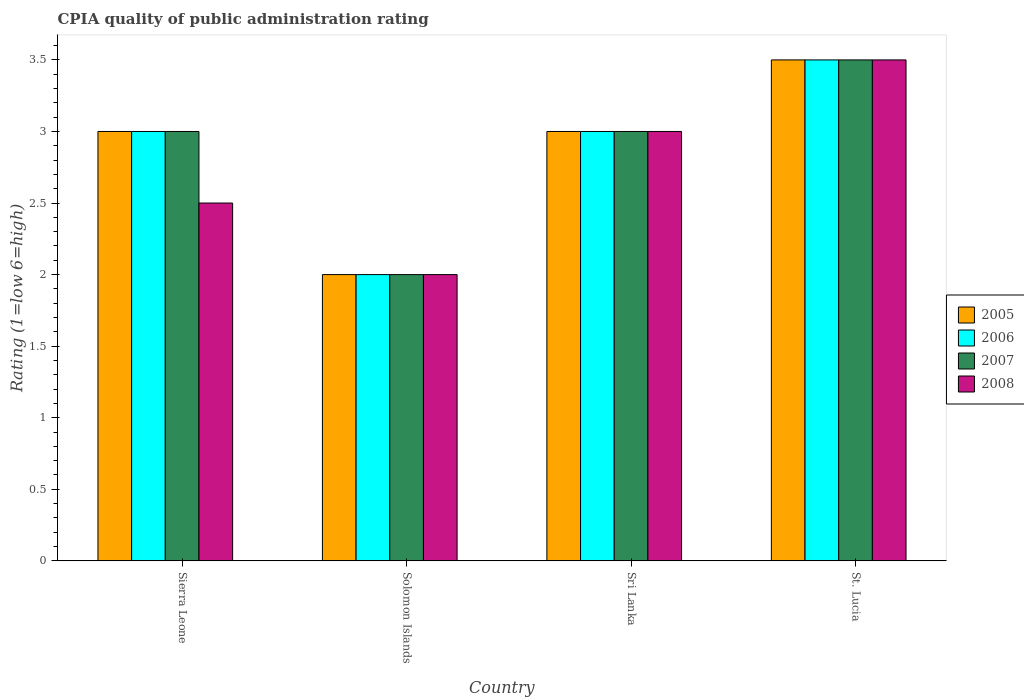How many different coloured bars are there?
Keep it short and to the point. 4. Are the number of bars per tick equal to the number of legend labels?
Your answer should be compact. Yes. How many bars are there on the 1st tick from the right?
Your answer should be very brief. 4. What is the label of the 1st group of bars from the left?
Keep it short and to the point. Sierra Leone. What is the CPIA rating in 2008 in Sierra Leone?
Offer a very short reply. 2.5. Across all countries, what is the minimum CPIA rating in 2008?
Offer a terse response. 2. In which country was the CPIA rating in 2005 maximum?
Keep it short and to the point. St. Lucia. In which country was the CPIA rating in 2006 minimum?
Ensure brevity in your answer.  Solomon Islands. What is the difference between the CPIA rating in 2005 in Sierra Leone and that in Sri Lanka?
Provide a short and direct response. 0. What is the average CPIA rating in 2007 per country?
Keep it short and to the point. 2.88. What is the ratio of the CPIA rating in 2008 in Sierra Leone to that in Sri Lanka?
Provide a succinct answer. 0.83. Is the CPIA rating in 2007 in Solomon Islands less than that in St. Lucia?
Provide a succinct answer. Yes. What is the difference between the highest and the second highest CPIA rating in 2005?
Your answer should be compact. -0.5. What is the difference between the highest and the lowest CPIA rating in 2008?
Your answer should be compact. 1.5. In how many countries, is the CPIA rating in 2005 greater than the average CPIA rating in 2005 taken over all countries?
Ensure brevity in your answer.  3. Is the sum of the CPIA rating in 2008 in Sierra Leone and Solomon Islands greater than the maximum CPIA rating in 2005 across all countries?
Ensure brevity in your answer.  Yes. Is it the case that in every country, the sum of the CPIA rating in 2006 and CPIA rating in 2008 is greater than the sum of CPIA rating in 2007 and CPIA rating in 2005?
Offer a very short reply. No. What does the 1st bar from the right in Sri Lanka represents?
Ensure brevity in your answer.  2008. Is it the case that in every country, the sum of the CPIA rating in 2007 and CPIA rating in 2008 is greater than the CPIA rating in 2005?
Provide a succinct answer. Yes. Are all the bars in the graph horizontal?
Keep it short and to the point. No. How many countries are there in the graph?
Provide a succinct answer. 4. How many legend labels are there?
Provide a succinct answer. 4. How are the legend labels stacked?
Provide a short and direct response. Vertical. What is the title of the graph?
Provide a short and direct response. CPIA quality of public administration rating. What is the label or title of the X-axis?
Keep it short and to the point. Country. What is the Rating (1=low 6=high) in 2008 in Sierra Leone?
Your answer should be compact. 2.5. What is the Rating (1=low 6=high) in 2005 in Sri Lanka?
Your answer should be very brief. 3. What is the Rating (1=low 6=high) in 2006 in Sri Lanka?
Provide a succinct answer. 3. What is the Rating (1=low 6=high) of 2007 in Sri Lanka?
Your answer should be very brief. 3. What is the Rating (1=low 6=high) in 2008 in Sri Lanka?
Provide a short and direct response. 3. What is the Rating (1=low 6=high) in 2006 in St. Lucia?
Make the answer very short. 3.5. What is the Rating (1=low 6=high) of 2008 in St. Lucia?
Your response must be concise. 3.5. Across all countries, what is the maximum Rating (1=low 6=high) of 2005?
Your answer should be very brief. 3.5. Across all countries, what is the maximum Rating (1=low 6=high) in 2007?
Offer a very short reply. 3.5. Across all countries, what is the maximum Rating (1=low 6=high) in 2008?
Give a very brief answer. 3.5. Across all countries, what is the minimum Rating (1=low 6=high) in 2005?
Keep it short and to the point. 2. What is the total Rating (1=low 6=high) of 2005 in the graph?
Make the answer very short. 11.5. What is the total Rating (1=low 6=high) in 2007 in the graph?
Provide a succinct answer. 11.5. What is the total Rating (1=low 6=high) of 2008 in the graph?
Provide a short and direct response. 11. What is the difference between the Rating (1=low 6=high) in 2006 in Sierra Leone and that in Solomon Islands?
Your answer should be very brief. 1. What is the difference between the Rating (1=low 6=high) of 2006 in Sierra Leone and that in St. Lucia?
Ensure brevity in your answer.  -0.5. What is the difference between the Rating (1=low 6=high) of 2007 in Sierra Leone and that in St. Lucia?
Offer a very short reply. -0.5. What is the difference between the Rating (1=low 6=high) of 2005 in Solomon Islands and that in Sri Lanka?
Your answer should be compact. -1. What is the difference between the Rating (1=low 6=high) of 2006 in Solomon Islands and that in Sri Lanka?
Offer a very short reply. -1. What is the difference between the Rating (1=low 6=high) of 2007 in Solomon Islands and that in Sri Lanka?
Make the answer very short. -1. What is the difference between the Rating (1=low 6=high) in 2008 in Solomon Islands and that in Sri Lanka?
Keep it short and to the point. -1. What is the difference between the Rating (1=low 6=high) of 2005 in Solomon Islands and that in St. Lucia?
Keep it short and to the point. -1.5. What is the difference between the Rating (1=low 6=high) in 2006 in Solomon Islands and that in St. Lucia?
Keep it short and to the point. -1.5. What is the difference between the Rating (1=low 6=high) of 2007 in Solomon Islands and that in St. Lucia?
Your response must be concise. -1.5. What is the difference between the Rating (1=low 6=high) of 2005 in Sri Lanka and that in St. Lucia?
Your answer should be very brief. -0.5. What is the difference between the Rating (1=low 6=high) in 2005 in Sierra Leone and the Rating (1=low 6=high) in 2006 in Solomon Islands?
Ensure brevity in your answer.  1. What is the difference between the Rating (1=low 6=high) of 2007 in Sierra Leone and the Rating (1=low 6=high) of 2008 in Solomon Islands?
Your response must be concise. 1. What is the difference between the Rating (1=low 6=high) of 2006 in Sierra Leone and the Rating (1=low 6=high) of 2008 in Sri Lanka?
Give a very brief answer. 0. What is the difference between the Rating (1=low 6=high) in 2005 in Sierra Leone and the Rating (1=low 6=high) in 2006 in St. Lucia?
Provide a succinct answer. -0.5. What is the difference between the Rating (1=low 6=high) in 2006 in Sierra Leone and the Rating (1=low 6=high) in 2007 in St. Lucia?
Offer a very short reply. -0.5. What is the difference between the Rating (1=low 6=high) of 2007 in Sierra Leone and the Rating (1=low 6=high) of 2008 in St. Lucia?
Provide a short and direct response. -0.5. What is the difference between the Rating (1=low 6=high) in 2005 in Solomon Islands and the Rating (1=low 6=high) in 2006 in Sri Lanka?
Give a very brief answer. -1. What is the difference between the Rating (1=low 6=high) in 2006 in Solomon Islands and the Rating (1=low 6=high) in 2007 in Sri Lanka?
Your response must be concise. -1. What is the difference between the Rating (1=low 6=high) of 2007 in Solomon Islands and the Rating (1=low 6=high) of 2008 in Sri Lanka?
Ensure brevity in your answer.  -1. What is the difference between the Rating (1=low 6=high) of 2005 in Solomon Islands and the Rating (1=low 6=high) of 2006 in St. Lucia?
Provide a short and direct response. -1.5. What is the difference between the Rating (1=low 6=high) in 2005 in Solomon Islands and the Rating (1=low 6=high) in 2007 in St. Lucia?
Provide a succinct answer. -1.5. What is the difference between the Rating (1=low 6=high) in 2005 in Solomon Islands and the Rating (1=low 6=high) in 2008 in St. Lucia?
Offer a terse response. -1.5. What is the difference between the Rating (1=low 6=high) of 2006 in Solomon Islands and the Rating (1=low 6=high) of 2007 in St. Lucia?
Keep it short and to the point. -1.5. What is the difference between the Rating (1=low 6=high) in 2006 in Solomon Islands and the Rating (1=low 6=high) in 2008 in St. Lucia?
Provide a short and direct response. -1.5. What is the difference between the Rating (1=low 6=high) of 2005 in Sri Lanka and the Rating (1=low 6=high) of 2006 in St. Lucia?
Your answer should be very brief. -0.5. What is the difference between the Rating (1=low 6=high) of 2005 in Sri Lanka and the Rating (1=low 6=high) of 2008 in St. Lucia?
Give a very brief answer. -0.5. What is the difference between the Rating (1=low 6=high) in 2006 in Sri Lanka and the Rating (1=low 6=high) in 2007 in St. Lucia?
Offer a terse response. -0.5. What is the difference between the Rating (1=low 6=high) in 2006 in Sri Lanka and the Rating (1=low 6=high) in 2008 in St. Lucia?
Offer a terse response. -0.5. What is the difference between the Rating (1=low 6=high) of 2007 in Sri Lanka and the Rating (1=low 6=high) of 2008 in St. Lucia?
Ensure brevity in your answer.  -0.5. What is the average Rating (1=low 6=high) of 2005 per country?
Your answer should be compact. 2.88. What is the average Rating (1=low 6=high) of 2006 per country?
Your response must be concise. 2.88. What is the average Rating (1=low 6=high) in 2007 per country?
Keep it short and to the point. 2.88. What is the average Rating (1=low 6=high) in 2008 per country?
Give a very brief answer. 2.75. What is the difference between the Rating (1=low 6=high) in 2006 and Rating (1=low 6=high) in 2007 in Sierra Leone?
Keep it short and to the point. 0. What is the difference between the Rating (1=low 6=high) of 2006 and Rating (1=low 6=high) of 2008 in Sierra Leone?
Make the answer very short. 0.5. What is the difference between the Rating (1=low 6=high) in 2007 and Rating (1=low 6=high) in 2008 in Sierra Leone?
Give a very brief answer. 0.5. What is the difference between the Rating (1=low 6=high) of 2005 and Rating (1=low 6=high) of 2007 in Solomon Islands?
Provide a succinct answer. 0. What is the difference between the Rating (1=low 6=high) of 2005 and Rating (1=low 6=high) of 2008 in Solomon Islands?
Ensure brevity in your answer.  0. What is the difference between the Rating (1=low 6=high) in 2006 and Rating (1=low 6=high) in 2007 in Solomon Islands?
Your answer should be very brief. 0. What is the difference between the Rating (1=low 6=high) of 2007 and Rating (1=low 6=high) of 2008 in Solomon Islands?
Give a very brief answer. 0. What is the difference between the Rating (1=low 6=high) in 2005 and Rating (1=low 6=high) in 2008 in Sri Lanka?
Keep it short and to the point. 0. What is the difference between the Rating (1=low 6=high) of 2005 and Rating (1=low 6=high) of 2007 in St. Lucia?
Give a very brief answer. 0. What is the difference between the Rating (1=low 6=high) of 2006 and Rating (1=low 6=high) of 2007 in St. Lucia?
Your answer should be very brief. 0. What is the difference between the Rating (1=low 6=high) of 2006 and Rating (1=low 6=high) of 2008 in St. Lucia?
Your response must be concise. 0. What is the difference between the Rating (1=low 6=high) of 2007 and Rating (1=low 6=high) of 2008 in St. Lucia?
Your response must be concise. 0. What is the ratio of the Rating (1=low 6=high) of 2007 in Sierra Leone to that in Solomon Islands?
Offer a very short reply. 1.5. What is the ratio of the Rating (1=low 6=high) of 2008 in Sierra Leone to that in Solomon Islands?
Your response must be concise. 1.25. What is the ratio of the Rating (1=low 6=high) of 2007 in Sierra Leone to that in St. Lucia?
Provide a short and direct response. 0.86. What is the ratio of the Rating (1=low 6=high) in 2005 in Solomon Islands to that in Sri Lanka?
Provide a short and direct response. 0.67. What is the ratio of the Rating (1=low 6=high) of 2008 in Solomon Islands to that in Sri Lanka?
Provide a short and direct response. 0.67. What is the ratio of the Rating (1=low 6=high) of 2005 in Solomon Islands to that in St. Lucia?
Offer a terse response. 0.57. What is the ratio of the Rating (1=low 6=high) of 2006 in Solomon Islands to that in St. Lucia?
Your answer should be very brief. 0.57. What is the ratio of the Rating (1=low 6=high) of 2006 in Sri Lanka to that in St. Lucia?
Give a very brief answer. 0.86. What is the ratio of the Rating (1=low 6=high) of 2007 in Sri Lanka to that in St. Lucia?
Give a very brief answer. 0.86. What is the ratio of the Rating (1=low 6=high) in 2008 in Sri Lanka to that in St. Lucia?
Give a very brief answer. 0.86. What is the difference between the highest and the second highest Rating (1=low 6=high) of 2005?
Offer a terse response. 0.5. What is the difference between the highest and the lowest Rating (1=low 6=high) of 2005?
Ensure brevity in your answer.  1.5. What is the difference between the highest and the lowest Rating (1=low 6=high) in 2006?
Provide a succinct answer. 1.5. 